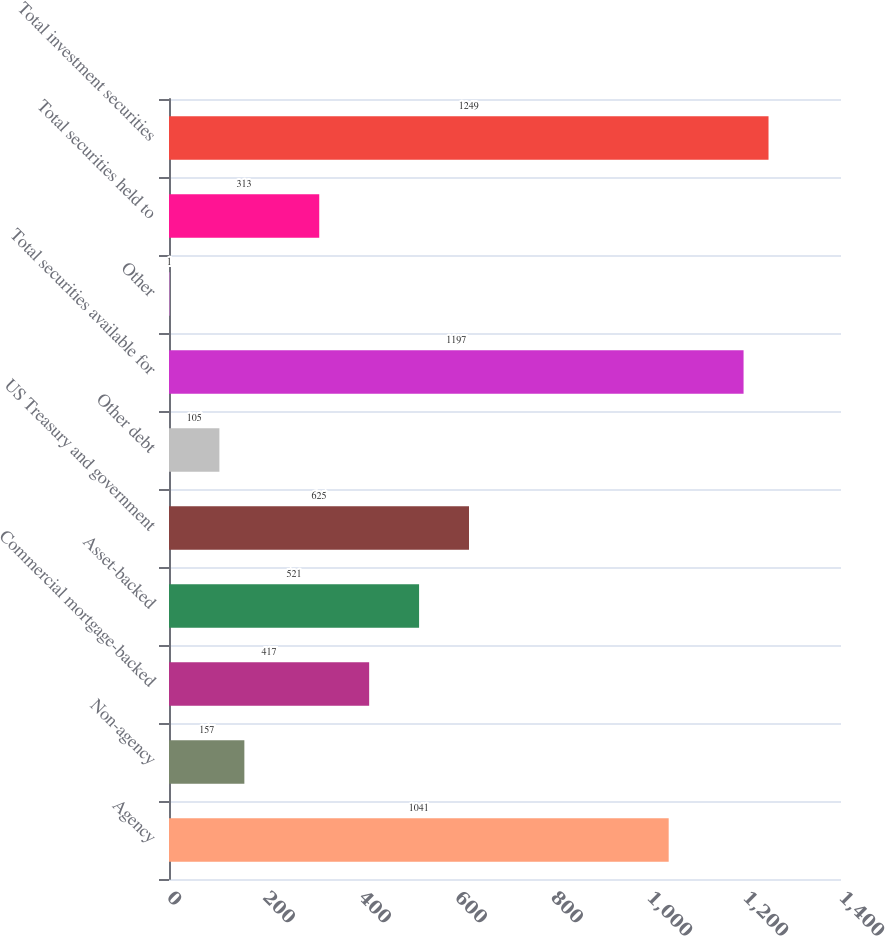<chart> <loc_0><loc_0><loc_500><loc_500><bar_chart><fcel>Agency<fcel>Non-agency<fcel>Commercial mortgage-backed<fcel>Asset-backed<fcel>US Treasury and government<fcel>Other debt<fcel>Total securities available for<fcel>Other<fcel>Total securities held to<fcel>Total investment securities<nl><fcel>1041<fcel>157<fcel>417<fcel>521<fcel>625<fcel>105<fcel>1197<fcel>1<fcel>313<fcel>1249<nl></chart> 